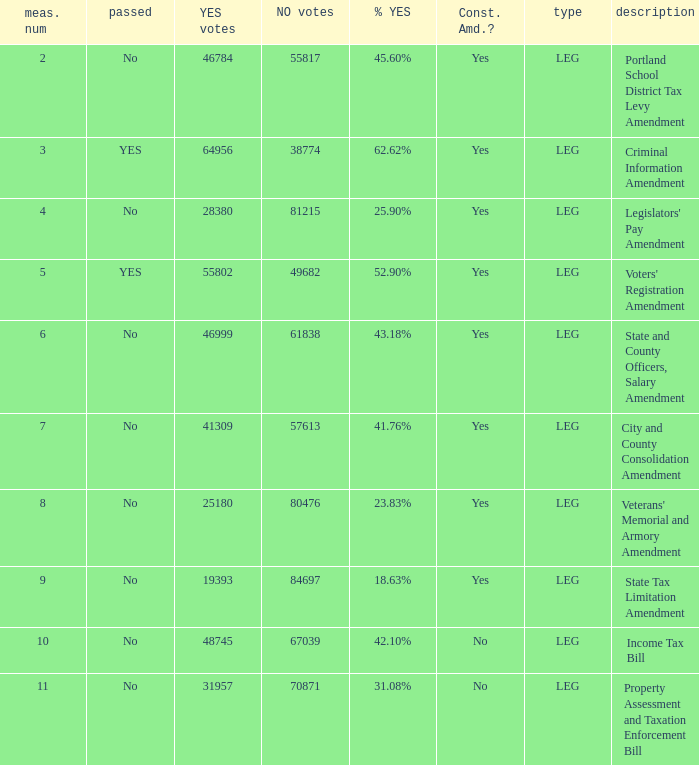60% affirmative votes? 55817.0. 